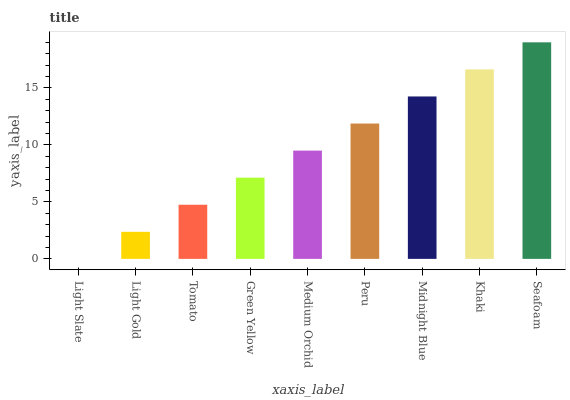Is Light Slate the minimum?
Answer yes or no. Yes. Is Seafoam the maximum?
Answer yes or no. Yes. Is Light Gold the minimum?
Answer yes or no. No. Is Light Gold the maximum?
Answer yes or no. No. Is Light Gold greater than Light Slate?
Answer yes or no. Yes. Is Light Slate less than Light Gold?
Answer yes or no. Yes. Is Light Slate greater than Light Gold?
Answer yes or no. No. Is Light Gold less than Light Slate?
Answer yes or no. No. Is Medium Orchid the high median?
Answer yes or no. Yes. Is Medium Orchid the low median?
Answer yes or no. Yes. Is Light Slate the high median?
Answer yes or no. No. Is Light Gold the low median?
Answer yes or no. No. 